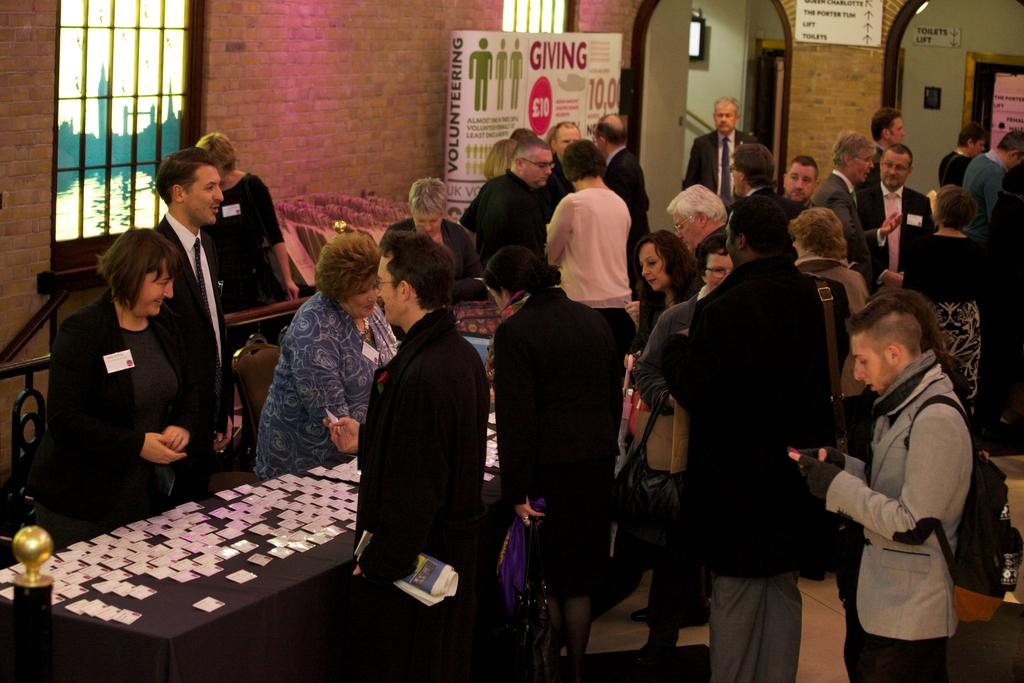What is the main subject of the image? The main subject of the image is a group of people. Can you describe any objects or items in the image? Yes, there is a card on a table in the image. What can be seen in the background of the image? There is a wall visible at the back side of the image. What type of joke is being told by the person driving the car in the image? There is no car or person driving in the image; it features a group of people and a card on a table. 